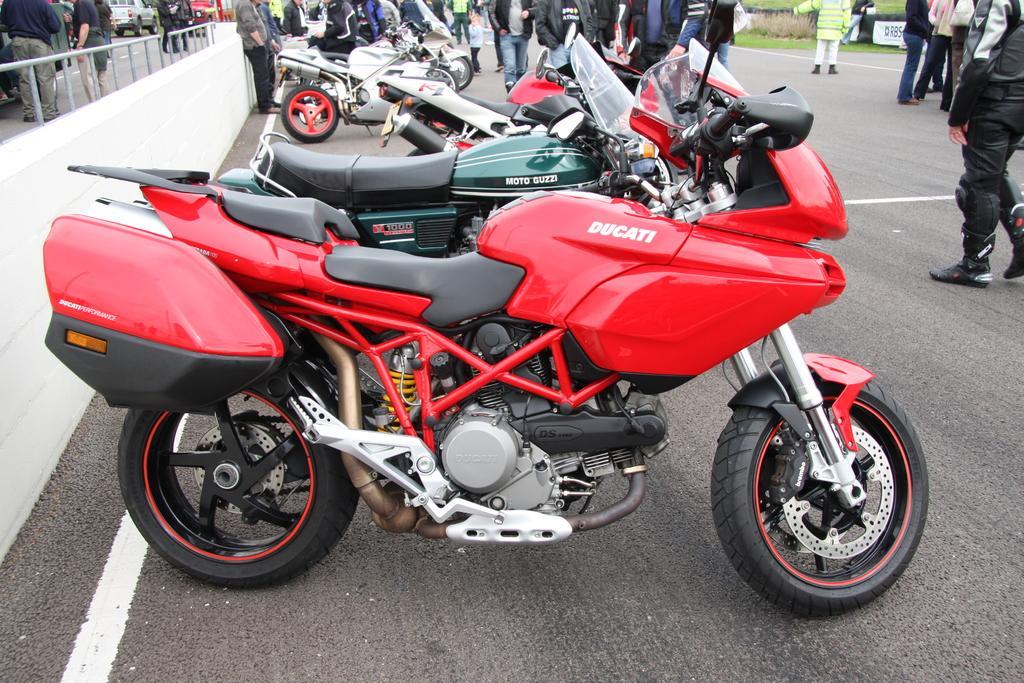Please provide a concise description of this image. In the center of the image a motorcycles is present. In the background of the image some persons are standing. On the left side of the image truck, wall, grills are present. At the top of the image board, grass are there. At the bottom of the image road is present. 